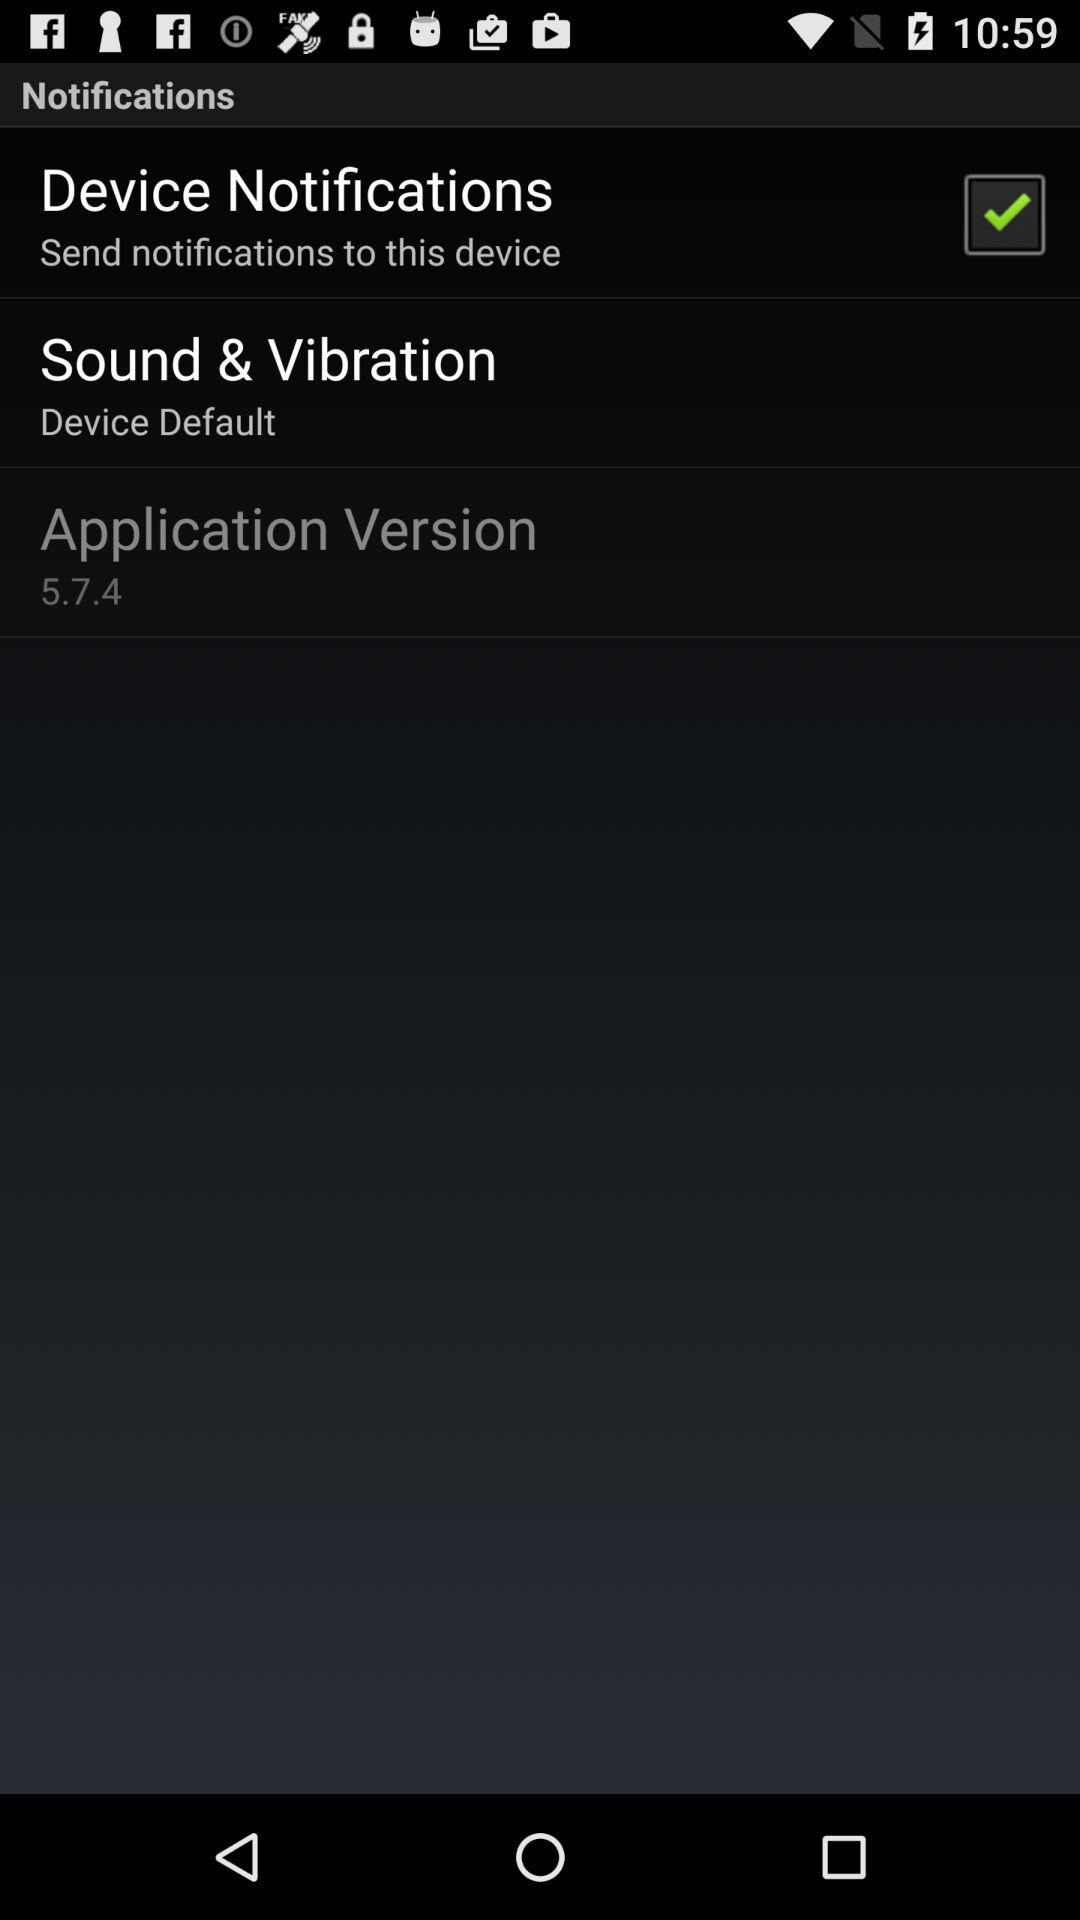What is the status of the "Device Notifications"? The status of the "Device Notifications" is "on". 